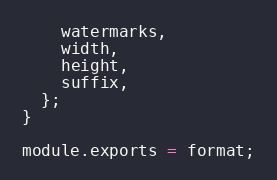Convert code to text. <code><loc_0><loc_0><loc_500><loc_500><_JavaScript_>    watermarks,
    width,
    height,
    suffix,
  };
}

module.exports = format;
</code> 